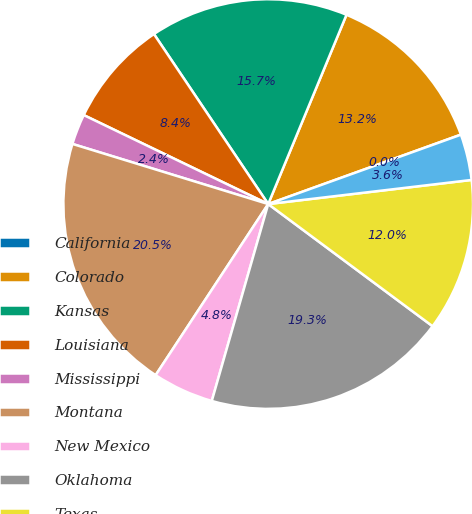Convert chart to OTSL. <chart><loc_0><loc_0><loc_500><loc_500><pie_chart><fcel>California<fcel>Colorado<fcel>Kansas<fcel>Louisiana<fcel>Mississippi<fcel>Montana<fcel>New Mexico<fcel>Oklahoma<fcel>Texas<fcel>Utah<nl><fcel>0.01%<fcel>13.25%<fcel>15.66%<fcel>8.43%<fcel>2.41%<fcel>20.48%<fcel>4.82%<fcel>19.27%<fcel>12.05%<fcel>3.62%<nl></chart> 